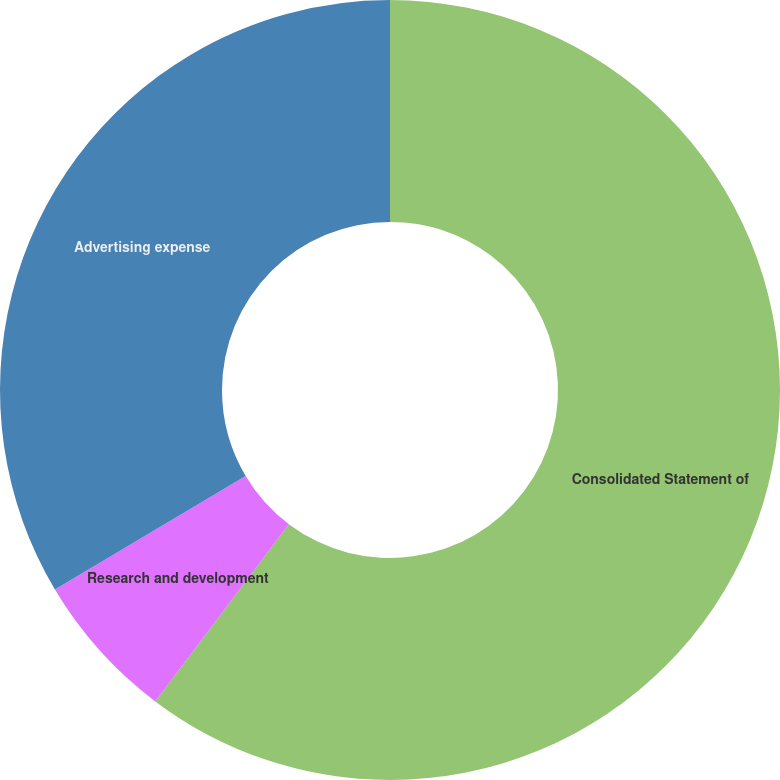Convert chart to OTSL. <chart><loc_0><loc_0><loc_500><loc_500><pie_chart><fcel>Consolidated Statement of<fcel>Research and development<fcel>Advertising expense<nl><fcel>60.28%<fcel>6.17%<fcel>33.55%<nl></chart> 